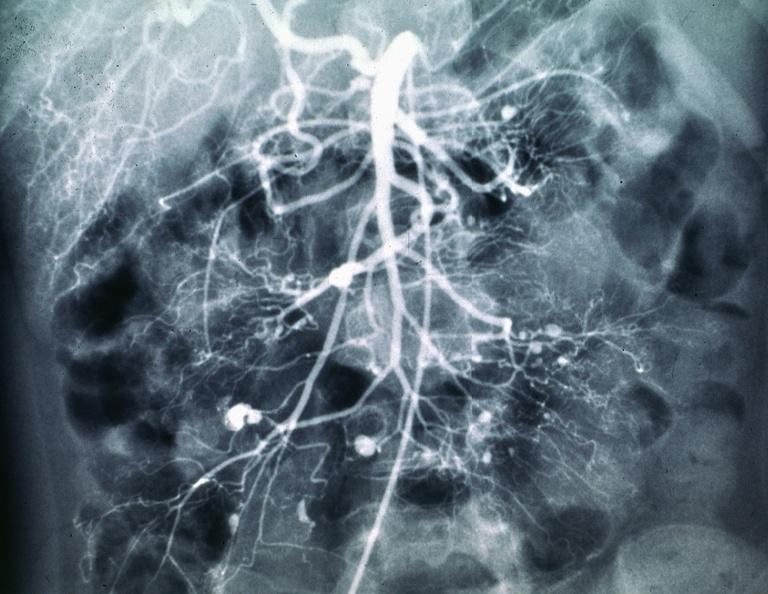what is present?
Answer the question using a single word or phrase. Abdomen 